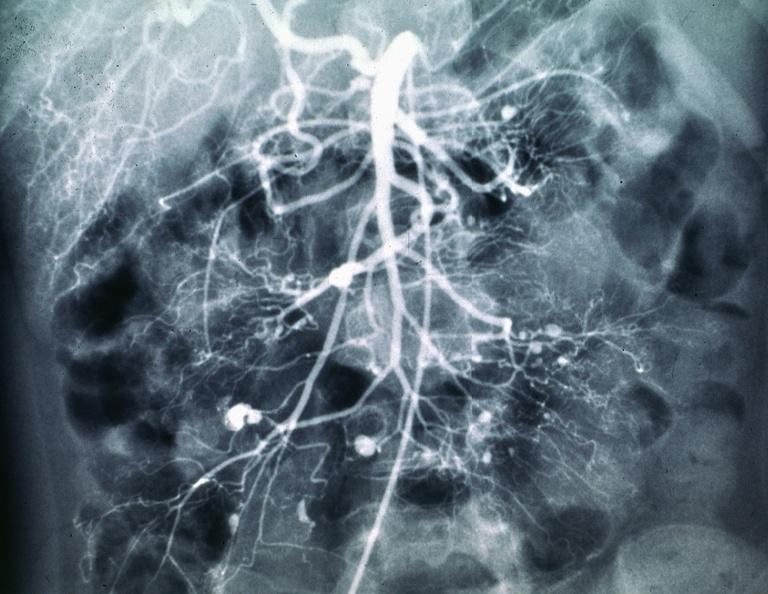what is present?
Answer the question using a single word or phrase. Abdomen 